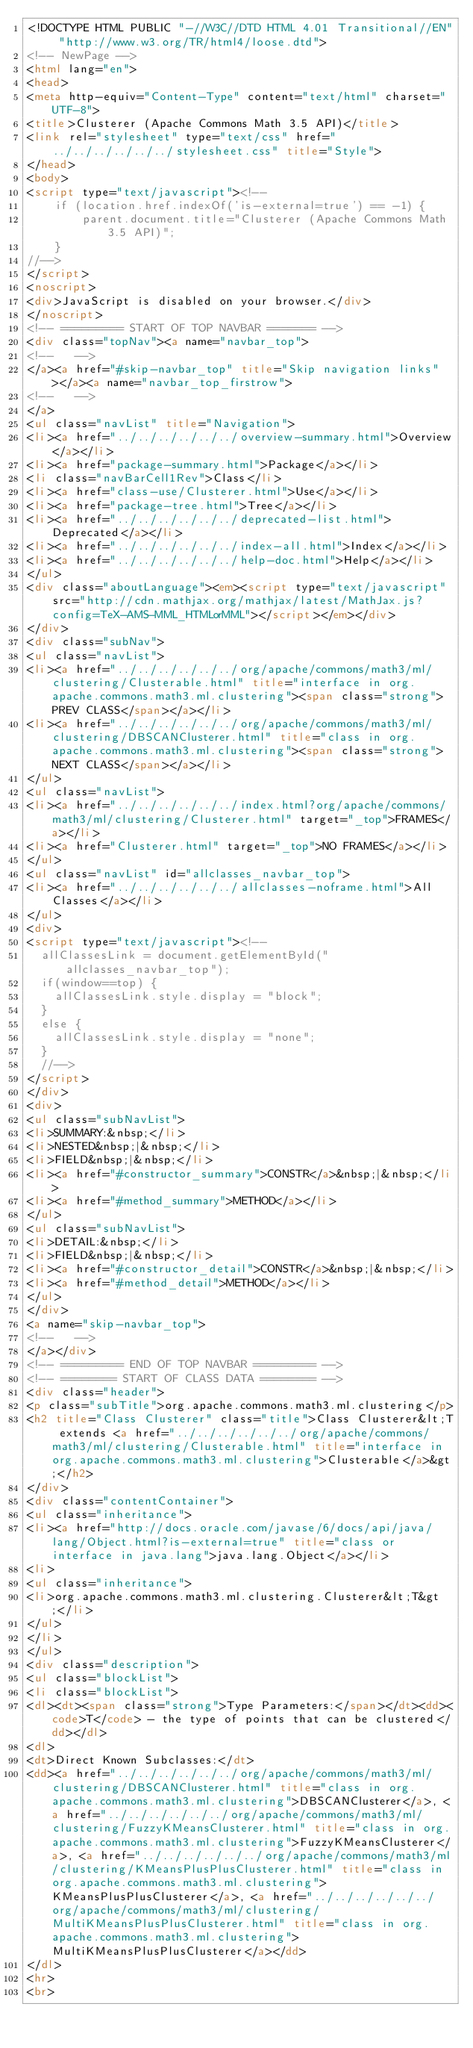Convert code to text. <code><loc_0><loc_0><loc_500><loc_500><_HTML_><!DOCTYPE HTML PUBLIC "-//W3C//DTD HTML 4.01 Transitional//EN" "http://www.w3.org/TR/html4/loose.dtd">
<!-- NewPage -->
<html lang="en">
<head>
<meta http-equiv="Content-Type" content="text/html" charset="UTF-8">
<title>Clusterer (Apache Commons Math 3.5 API)</title>
<link rel="stylesheet" type="text/css" href="../../../../../../stylesheet.css" title="Style">
</head>
<body>
<script type="text/javascript"><!--
    if (location.href.indexOf('is-external=true') == -1) {
        parent.document.title="Clusterer (Apache Commons Math 3.5 API)";
    }
//-->
</script>
<noscript>
<div>JavaScript is disabled on your browser.</div>
</noscript>
<!-- ========= START OF TOP NAVBAR ======= -->
<div class="topNav"><a name="navbar_top">
<!--   -->
</a><a href="#skip-navbar_top" title="Skip navigation links"></a><a name="navbar_top_firstrow">
<!--   -->
</a>
<ul class="navList" title="Navigation">
<li><a href="../../../../../../overview-summary.html">Overview</a></li>
<li><a href="package-summary.html">Package</a></li>
<li class="navBarCell1Rev">Class</li>
<li><a href="class-use/Clusterer.html">Use</a></li>
<li><a href="package-tree.html">Tree</a></li>
<li><a href="../../../../../../deprecated-list.html">Deprecated</a></li>
<li><a href="../../../../../../index-all.html">Index</a></li>
<li><a href="../../../../../../help-doc.html">Help</a></li>
</ul>
<div class="aboutLanguage"><em><script type="text/javascript" src="http://cdn.mathjax.org/mathjax/latest/MathJax.js?config=TeX-AMS-MML_HTMLorMML"></script></em></div>
</div>
<div class="subNav">
<ul class="navList">
<li><a href="../../../../../../org/apache/commons/math3/ml/clustering/Clusterable.html" title="interface in org.apache.commons.math3.ml.clustering"><span class="strong">PREV CLASS</span></a></li>
<li><a href="../../../../../../org/apache/commons/math3/ml/clustering/DBSCANClusterer.html" title="class in org.apache.commons.math3.ml.clustering"><span class="strong">NEXT CLASS</span></a></li>
</ul>
<ul class="navList">
<li><a href="../../../../../../index.html?org/apache/commons/math3/ml/clustering/Clusterer.html" target="_top">FRAMES</a></li>
<li><a href="Clusterer.html" target="_top">NO FRAMES</a></li>
</ul>
<ul class="navList" id="allclasses_navbar_top">
<li><a href="../../../../../../allclasses-noframe.html">All Classes</a></li>
</ul>
<div>
<script type="text/javascript"><!--
  allClassesLink = document.getElementById("allclasses_navbar_top");
  if(window==top) {
    allClassesLink.style.display = "block";
  }
  else {
    allClassesLink.style.display = "none";
  }
  //-->
</script>
</div>
<div>
<ul class="subNavList">
<li>SUMMARY:&nbsp;</li>
<li>NESTED&nbsp;|&nbsp;</li>
<li>FIELD&nbsp;|&nbsp;</li>
<li><a href="#constructor_summary">CONSTR</a>&nbsp;|&nbsp;</li>
<li><a href="#method_summary">METHOD</a></li>
</ul>
<ul class="subNavList">
<li>DETAIL:&nbsp;</li>
<li>FIELD&nbsp;|&nbsp;</li>
<li><a href="#constructor_detail">CONSTR</a>&nbsp;|&nbsp;</li>
<li><a href="#method_detail">METHOD</a></li>
</ul>
</div>
<a name="skip-navbar_top">
<!--   -->
</a></div>
<!-- ========= END OF TOP NAVBAR ========= -->
<!-- ======== START OF CLASS DATA ======== -->
<div class="header">
<p class="subTitle">org.apache.commons.math3.ml.clustering</p>
<h2 title="Class Clusterer" class="title">Class Clusterer&lt;T extends <a href="../../../../../../org/apache/commons/math3/ml/clustering/Clusterable.html" title="interface in org.apache.commons.math3.ml.clustering">Clusterable</a>&gt;</h2>
</div>
<div class="contentContainer">
<ul class="inheritance">
<li><a href="http://docs.oracle.com/javase/6/docs/api/java/lang/Object.html?is-external=true" title="class or interface in java.lang">java.lang.Object</a></li>
<li>
<ul class="inheritance">
<li>org.apache.commons.math3.ml.clustering.Clusterer&lt;T&gt;</li>
</ul>
</li>
</ul>
<div class="description">
<ul class="blockList">
<li class="blockList">
<dl><dt><span class="strong">Type Parameters:</span></dt><dd><code>T</code> - the type of points that can be clustered</dd></dl>
<dl>
<dt>Direct Known Subclasses:</dt>
<dd><a href="../../../../../../org/apache/commons/math3/ml/clustering/DBSCANClusterer.html" title="class in org.apache.commons.math3.ml.clustering">DBSCANClusterer</a>, <a href="../../../../../../org/apache/commons/math3/ml/clustering/FuzzyKMeansClusterer.html" title="class in org.apache.commons.math3.ml.clustering">FuzzyKMeansClusterer</a>, <a href="../../../../../../org/apache/commons/math3/ml/clustering/KMeansPlusPlusClusterer.html" title="class in org.apache.commons.math3.ml.clustering">KMeansPlusPlusClusterer</a>, <a href="../../../../../../org/apache/commons/math3/ml/clustering/MultiKMeansPlusPlusClusterer.html" title="class in org.apache.commons.math3.ml.clustering">MultiKMeansPlusPlusClusterer</a></dd>
</dl>
<hr>
<br></code> 